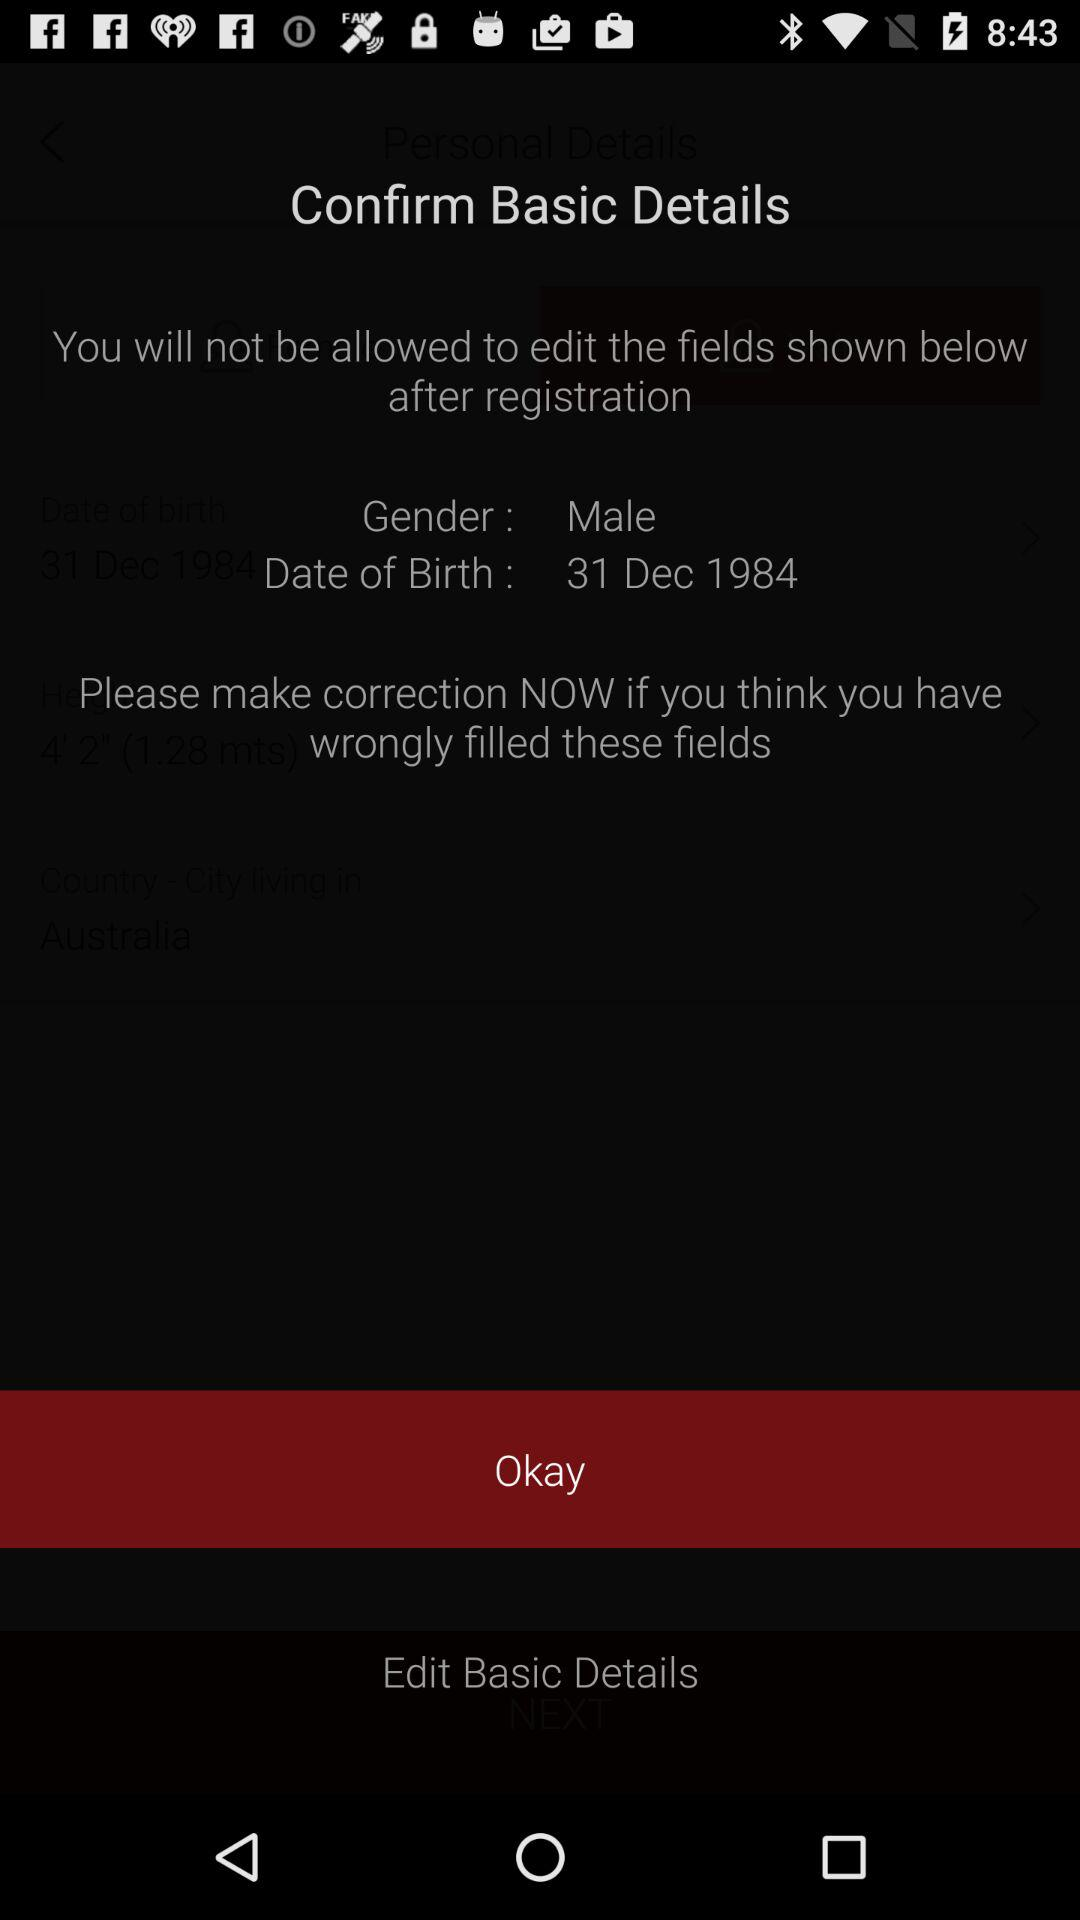What is the given date of birth? The given date of birth is December 31, 1984. 